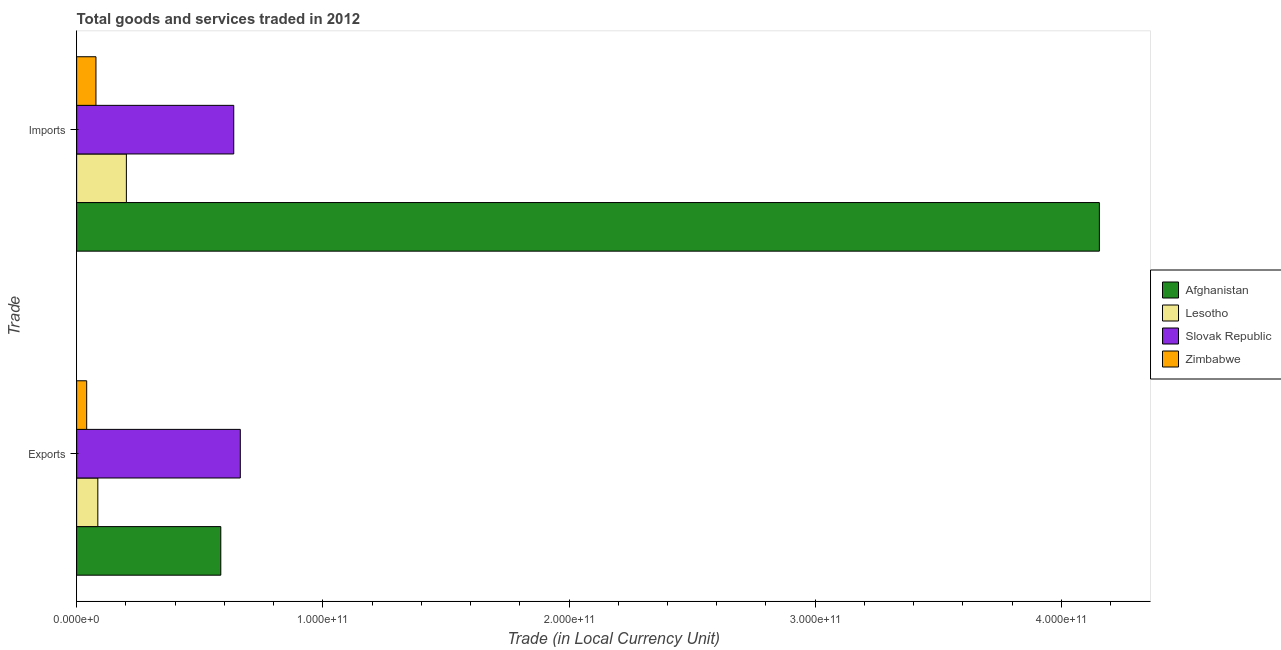How many groups of bars are there?
Provide a succinct answer. 2. Are the number of bars on each tick of the Y-axis equal?
Give a very brief answer. Yes. How many bars are there on the 2nd tick from the top?
Offer a terse response. 4. How many bars are there on the 2nd tick from the bottom?
Your answer should be very brief. 4. What is the label of the 1st group of bars from the top?
Offer a very short reply. Imports. What is the imports of goods and services in Lesotho?
Give a very brief answer. 2.02e+1. Across all countries, what is the maximum export of goods and services?
Your response must be concise. 6.65e+1. Across all countries, what is the minimum imports of goods and services?
Offer a very short reply. 7.83e+09. In which country was the export of goods and services maximum?
Offer a terse response. Slovak Republic. In which country was the imports of goods and services minimum?
Your answer should be compact. Zimbabwe. What is the total imports of goods and services in the graph?
Offer a very short reply. 5.07e+11. What is the difference between the imports of goods and services in Slovak Republic and that in Afghanistan?
Make the answer very short. -3.52e+11. What is the difference between the export of goods and services in Lesotho and the imports of goods and services in Slovak Republic?
Make the answer very short. -5.52e+1. What is the average export of goods and services per country?
Provide a short and direct response. 3.44e+1. What is the difference between the export of goods and services and imports of goods and services in Zimbabwe?
Keep it short and to the point. -3.76e+09. What is the ratio of the export of goods and services in Slovak Republic to that in Lesotho?
Give a very brief answer. 7.73. In how many countries, is the export of goods and services greater than the average export of goods and services taken over all countries?
Offer a terse response. 2. What does the 3rd bar from the top in Imports represents?
Offer a very short reply. Lesotho. What does the 4th bar from the bottom in Imports represents?
Your response must be concise. Zimbabwe. How many bars are there?
Your answer should be very brief. 8. Are all the bars in the graph horizontal?
Provide a succinct answer. Yes. How many countries are there in the graph?
Your answer should be very brief. 4. What is the difference between two consecutive major ticks on the X-axis?
Your response must be concise. 1.00e+11. Are the values on the major ticks of X-axis written in scientific E-notation?
Offer a terse response. Yes. Does the graph contain grids?
Your answer should be compact. No. What is the title of the graph?
Offer a very short reply. Total goods and services traded in 2012. What is the label or title of the X-axis?
Provide a short and direct response. Trade (in Local Currency Unit). What is the label or title of the Y-axis?
Give a very brief answer. Trade. What is the Trade (in Local Currency Unit) of Afghanistan in Exports?
Ensure brevity in your answer.  5.86e+1. What is the Trade (in Local Currency Unit) of Lesotho in Exports?
Give a very brief answer. 8.60e+09. What is the Trade (in Local Currency Unit) in Slovak Republic in Exports?
Keep it short and to the point. 6.65e+1. What is the Trade (in Local Currency Unit) in Zimbabwe in Exports?
Your answer should be compact. 4.08e+09. What is the Trade (in Local Currency Unit) of Afghanistan in Imports?
Make the answer very short. 4.15e+11. What is the Trade (in Local Currency Unit) of Lesotho in Imports?
Offer a very short reply. 2.02e+1. What is the Trade (in Local Currency Unit) in Slovak Republic in Imports?
Ensure brevity in your answer.  6.38e+1. What is the Trade (in Local Currency Unit) in Zimbabwe in Imports?
Offer a very short reply. 7.83e+09. Across all Trade, what is the maximum Trade (in Local Currency Unit) in Afghanistan?
Your response must be concise. 4.15e+11. Across all Trade, what is the maximum Trade (in Local Currency Unit) of Lesotho?
Provide a short and direct response. 2.02e+1. Across all Trade, what is the maximum Trade (in Local Currency Unit) in Slovak Republic?
Offer a very short reply. 6.65e+1. Across all Trade, what is the maximum Trade (in Local Currency Unit) in Zimbabwe?
Offer a very short reply. 7.83e+09. Across all Trade, what is the minimum Trade (in Local Currency Unit) in Afghanistan?
Offer a terse response. 5.86e+1. Across all Trade, what is the minimum Trade (in Local Currency Unit) in Lesotho?
Offer a terse response. 8.60e+09. Across all Trade, what is the minimum Trade (in Local Currency Unit) in Slovak Republic?
Give a very brief answer. 6.38e+1. Across all Trade, what is the minimum Trade (in Local Currency Unit) in Zimbabwe?
Make the answer very short. 4.08e+09. What is the total Trade (in Local Currency Unit) in Afghanistan in the graph?
Your answer should be compact. 4.74e+11. What is the total Trade (in Local Currency Unit) of Lesotho in the graph?
Ensure brevity in your answer.  2.88e+1. What is the total Trade (in Local Currency Unit) in Slovak Republic in the graph?
Provide a short and direct response. 1.30e+11. What is the total Trade (in Local Currency Unit) in Zimbabwe in the graph?
Give a very brief answer. 1.19e+1. What is the difference between the Trade (in Local Currency Unit) of Afghanistan in Exports and that in Imports?
Provide a succinct answer. -3.57e+11. What is the difference between the Trade (in Local Currency Unit) of Lesotho in Exports and that in Imports?
Offer a terse response. -1.16e+1. What is the difference between the Trade (in Local Currency Unit) in Slovak Republic in Exports and that in Imports?
Your response must be concise. 2.67e+09. What is the difference between the Trade (in Local Currency Unit) in Zimbabwe in Exports and that in Imports?
Your response must be concise. -3.76e+09. What is the difference between the Trade (in Local Currency Unit) of Afghanistan in Exports and the Trade (in Local Currency Unit) of Lesotho in Imports?
Your answer should be very brief. 3.84e+1. What is the difference between the Trade (in Local Currency Unit) in Afghanistan in Exports and the Trade (in Local Currency Unit) in Slovak Republic in Imports?
Offer a terse response. -5.26e+09. What is the difference between the Trade (in Local Currency Unit) of Afghanistan in Exports and the Trade (in Local Currency Unit) of Zimbabwe in Imports?
Offer a terse response. 5.07e+1. What is the difference between the Trade (in Local Currency Unit) of Lesotho in Exports and the Trade (in Local Currency Unit) of Slovak Republic in Imports?
Give a very brief answer. -5.52e+1. What is the difference between the Trade (in Local Currency Unit) of Lesotho in Exports and the Trade (in Local Currency Unit) of Zimbabwe in Imports?
Offer a terse response. 7.63e+08. What is the difference between the Trade (in Local Currency Unit) in Slovak Republic in Exports and the Trade (in Local Currency Unit) in Zimbabwe in Imports?
Your response must be concise. 5.86e+1. What is the average Trade (in Local Currency Unit) in Afghanistan per Trade?
Offer a terse response. 2.37e+11. What is the average Trade (in Local Currency Unit) of Lesotho per Trade?
Your answer should be compact. 1.44e+1. What is the average Trade (in Local Currency Unit) of Slovak Republic per Trade?
Offer a very short reply. 6.51e+1. What is the average Trade (in Local Currency Unit) of Zimbabwe per Trade?
Offer a terse response. 5.96e+09. What is the difference between the Trade (in Local Currency Unit) of Afghanistan and Trade (in Local Currency Unit) of Lesotho in Exports?
Give a very brief answer. 5.00e+1. What is the difference between the Trade (in Local Currency Unit) in Afghanistan and Trade (in Local Currency Unit) in Slovak Republic in Exports?
Ensure brevity in your answer.  -7.92e+09. What is the difference between the Trade (in Local Currency Unit) in Afghanistan and Trade (in Local Currency Unit) in Zimbabwe in Exports?
Give a very brief answer. 5.45e+1. What is the difference between the Trade (in Local Currency Unit) in Lesotho and Trade (in Local Currency Unit) in Slovak Republic in Exports?
Provide a short and direct response. -5.79e+1. What is the difference between the Trade (in Local Currency Unit) in Lesotho and Trade (in Local Currency Unit) in Zimbabwe in Exports?
Provide a succinct answer. 4.52e+09. What is the difference between the Trade (in Local Currency Unit) of Slovak Republic and Trade (in Local Currency Unit) of Zimbabwe in Exports?
Ensure brevity in your answer.  6.24e+1. What is the difference between the Trade (in Local Currency Unit) of Afghanistan and Trade (in Local Currency Unit) of Lesotho in Imports?
Make the answer very short. 3.95e+11. What is the difference between the Trade (in Local Currency Unit) of Afghanistan and Trade (in Local Currency Unit) of Slovak Republic in Imports?
Offer a terse response. 3.52e+11. What is the difference between the Trade (in Local Currency Unit) of Afghanistan and Trade (in Local Currency Unit) of Zimbabwe in Imports?
Keep it short and to the point. 4.08e+11. What is the difference between the Trade (in Local Currency Unit) in Lesotho and Trade (in Local Currency Unit) in Slovak Republic in Imports?
Your answer should be compact. -4.36e+1. What is the difference between the Trade (in Local Currency Unit) in Lesotho and Trade (in Local Currency Unit) in Zimbabwe in Imports?
Offer a terse response. 1.24e+1. What is the difference between the Trade (in Local Currency Unit) of Slovak Republic and Trade (in Local Currency Unit) of Zimbabwe in Imports?
Make the answer very short. 5.60e+1. What is the ratio of the Trade (in Local Currency Unit) of Afghanistan in Exports to that in Imports?
Your answer should be very brief. 0.14. What is the ratio of the Trade (in Local Currency Unit) in Lesotho in Exports to that in Imports?
Your answer should be very brief. 0.43. What is the ratio of the Trade (in Local Currency Unit) in Slovak Republic in Exports to that in Imports?
Offer a terse response. 1.04. What is the ratio of the Trade (in Local Currency Unit) in Zimbabwe in Exports to that in Imports?
Your answer should be very brief. 0.52. What is the difference between the highest and the second highest Trade (in Local Currency Unit) in Afghanistan?
Provide a succinct answer. 3.57e+11. What is the difference between the highest and the second highest Trade (in Local Currency Unit) of Lesotho?
Provide a succinct answer. 1.16e+1. What is the difference between the highest and the second highest Trade (in Local Currency Unit) of Slovak Republic?
Your answer should be compact. 2.67e+09. What is the difference between the highest and the second highest Trade (in Local Currency Unit) of Zimbabwe?
Ensure brevity in your answer.  3.76e+09. What is the difference between the highest and the lowest Trade (in Local Currency Unit) of Afghanistan?
Provide a succinct answer. 3.57e+11. What is the difference between the highest and the lowest Trade (in Local Currency Unit) of Lesotho?
Your answer should be compact. 1.16e+1. What is the difference between the highest and the lowest Trade (in Local Currency Unit) in Slovak Republic?
Give a very brief answer. 2.67e+09. What is the difference between the highest and the lowest Trade (in Local Currency Unit) of Zimbabwe?
Keep it short and to the point. 3.76e+09. 